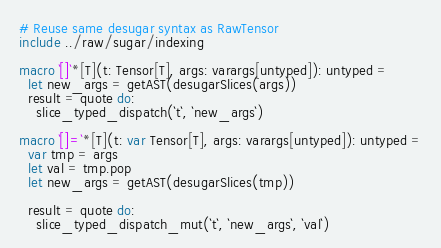<code> <loc_0><loc_0><loc_500><loc_500><_Nim_># Reuse same desugar syntax as RawTensor
include ../raw/sugar/indexing

macro `[]`*[T](t: Tensor[T], args: varargs[untyped]): untyped =
  let new_args = getAST(desugarSlices(args))
  result = quote do:
    slice_typed_dispatch(`t`, `new_args`)

macro `[]=`*[T](t: var Tensor[T], args: varargs[untyped]): untyped =
  var tmp = args
  let val = tmp.pop
  let new_args = getAST(desugarSlices(tmp))

  result = quote do:
    slice_typed_dispatch_mut(`t`, `new_args`, `val`)
</code> 